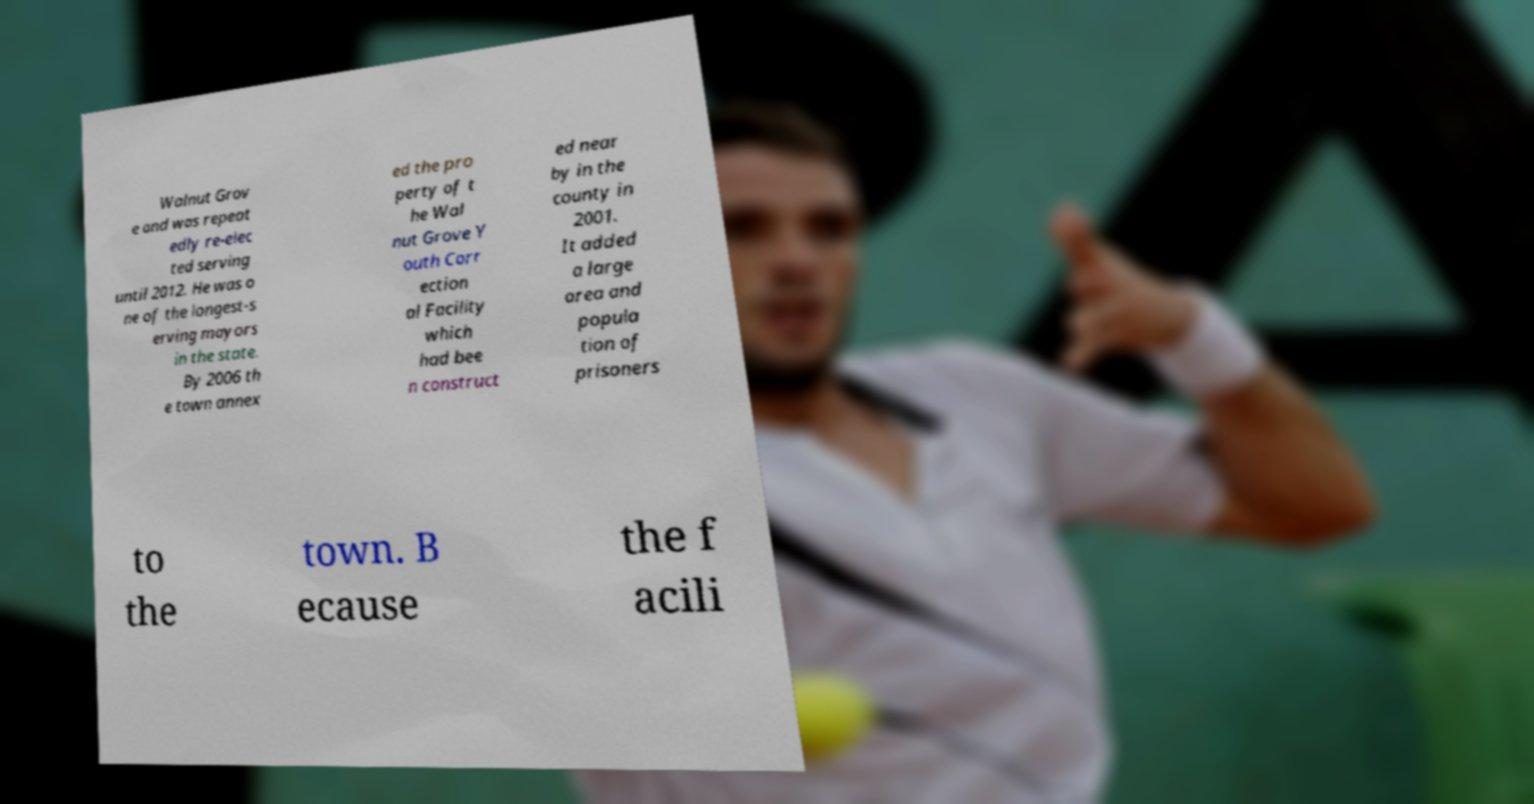For documentation purposes, I need the text within this image transcribed. Could you provide that? Walnut Grov e and was repeat edly re-elec ted serving until 2012. He was o ne of the longest-s erving mayors in the state. By 2006 th e town annex ed the pro perty of t he Wal nut Grove Y outh Corr ection al Facility which had bee n construct ed near by in the county in 2001. It added a large area and popula tion of prisoners to the town. B ecause the f acili 